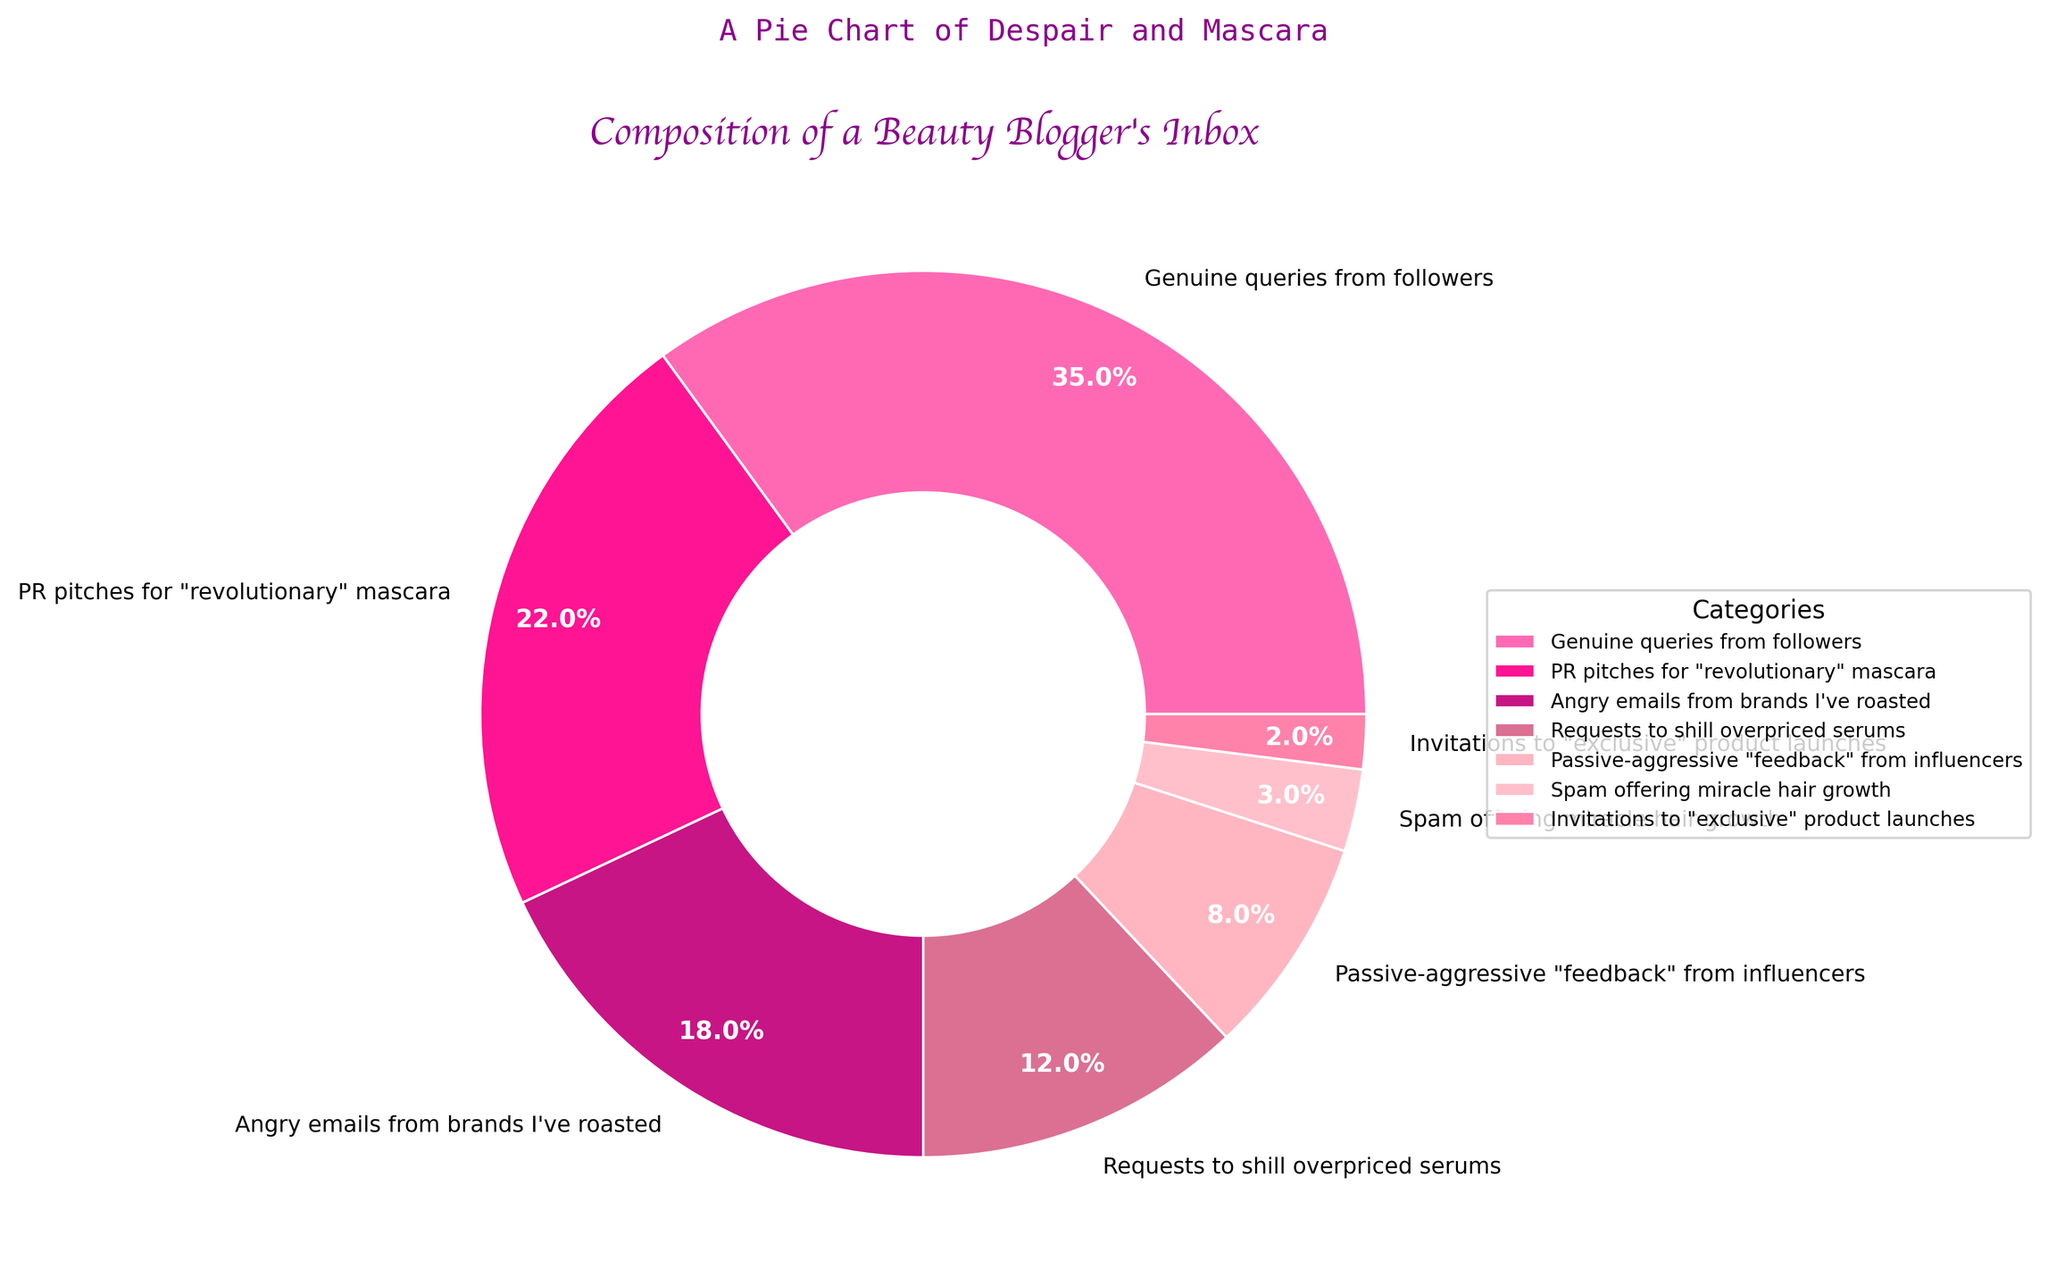What percentage of the inbox does PR pitches for "revolutionary" mascara and requests to shill overpriced serums together account for? Add the percentage of PR pitches for "revolutionary" mascara (22%) to the percentage of requests to shill overpriced serums (12%). 22% + 12% = 34%.
Answer: 34% Which category has the smallest percentage in the beauty blogger's inbox? Look for the smallest percentage among all the categories listed in the pie chart. The category with 2% is invitations to "exclusive" product launches.
Answer: Invitations to "exclusive" product launches How much greater is the percentage of genuine queries from followers compared to spam offering miracle hair growth? Subtract the percentage of spam offering miracle hair growth (3%) from the percentage of genuine queries from followers (35%). 35% - 3% = 32%.
Answer: 32% Which has a higher percentage: passive-aggressive "feedback" from influencers or angry emails from brands? Compare the percentage of passive-aggressive "feedback" from influencers (8%) with the percentage of angry emails from brands (18%). 18% is greater than 8%.
Answer: Angry emails from brands How many categories have a percentage equal to or above 10%? Count the categories with percentages equal to or greater than 10%. These are genuine queries from followers (35%), PR pitches for "revolutionary" mascara (22%), angry emails from brands I've roasted (18%), and requests to shill overpriced serums (12%). There are 4 such categories.
Answer: 4 If you combined the percentages of spam offering miracle hair growth and invitations to "exclusive" product launches, would their total percentage be greater than passive-aggressive "feedback" from influencers? Add the percentages of spam offering miracle hair growth (3%) and invitations to "exclusive" product launches (2%). 3% + 2% = 5%. Compare this total (5%) with passive-aggressive "feedback" from influencers (8%). 5% is less than 8%.
Answer: No What's the difference in percentage between the largest and smallest categories? Subtract the percentage of the smallest category (invitations to "exclusive" product launches at 2%) from the percentage of the largest category (genuine queries from followers at 35%). 35% - 2% = 33%.
Answer: 33% What percentage of the inbox do non-genuine categories (everything except genuine queries from followers) account for? Subtract the percentage of genuine queries from followers (35%) from 100%. 100% - 35% = 65%.
Answer: 65% Is the percentage of angry emails from brands higher than the combined total of passive-aggressive "feedback" from influencers and invitations to "exclusive" product launches? Add the percentages of passive-aggressive "feedback" from influencers (8%) and invitations to "exclusive" product launches (2%). 8% + 2% = 10%. Compare this total (10%) with the percentage of angry emails from brands (18%). 18% is greater than 10%.
Answer: Yes 